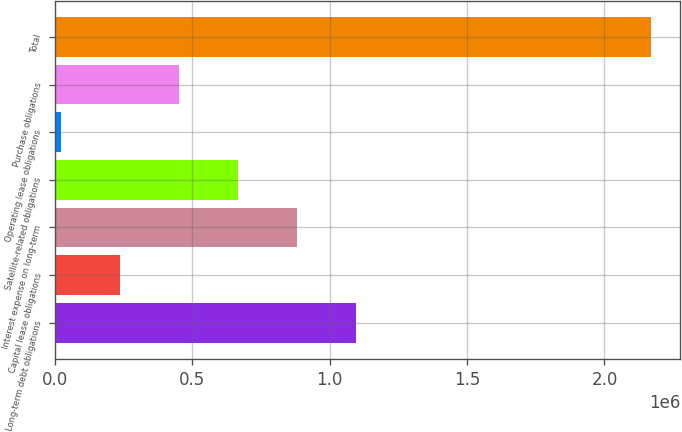Convert chart to OTSL. <chart><loc_0><loc_0><loc_500><loc_500><bar_chart><fcel>Long-term debt obligations<fcel>Capital lease obligations<fcel>Interest expense on long-term<fcel>Satellite-related obligations<fcel>Operating lease obligations<fcel>Purchase obligations<fcel>Total<nl><fcel>1.09415e+06<fcel>235320<fcel>879442<fcel>664735<fcel>20613<fcel>450027<fcel>2.16768e+06<nl></chart> 